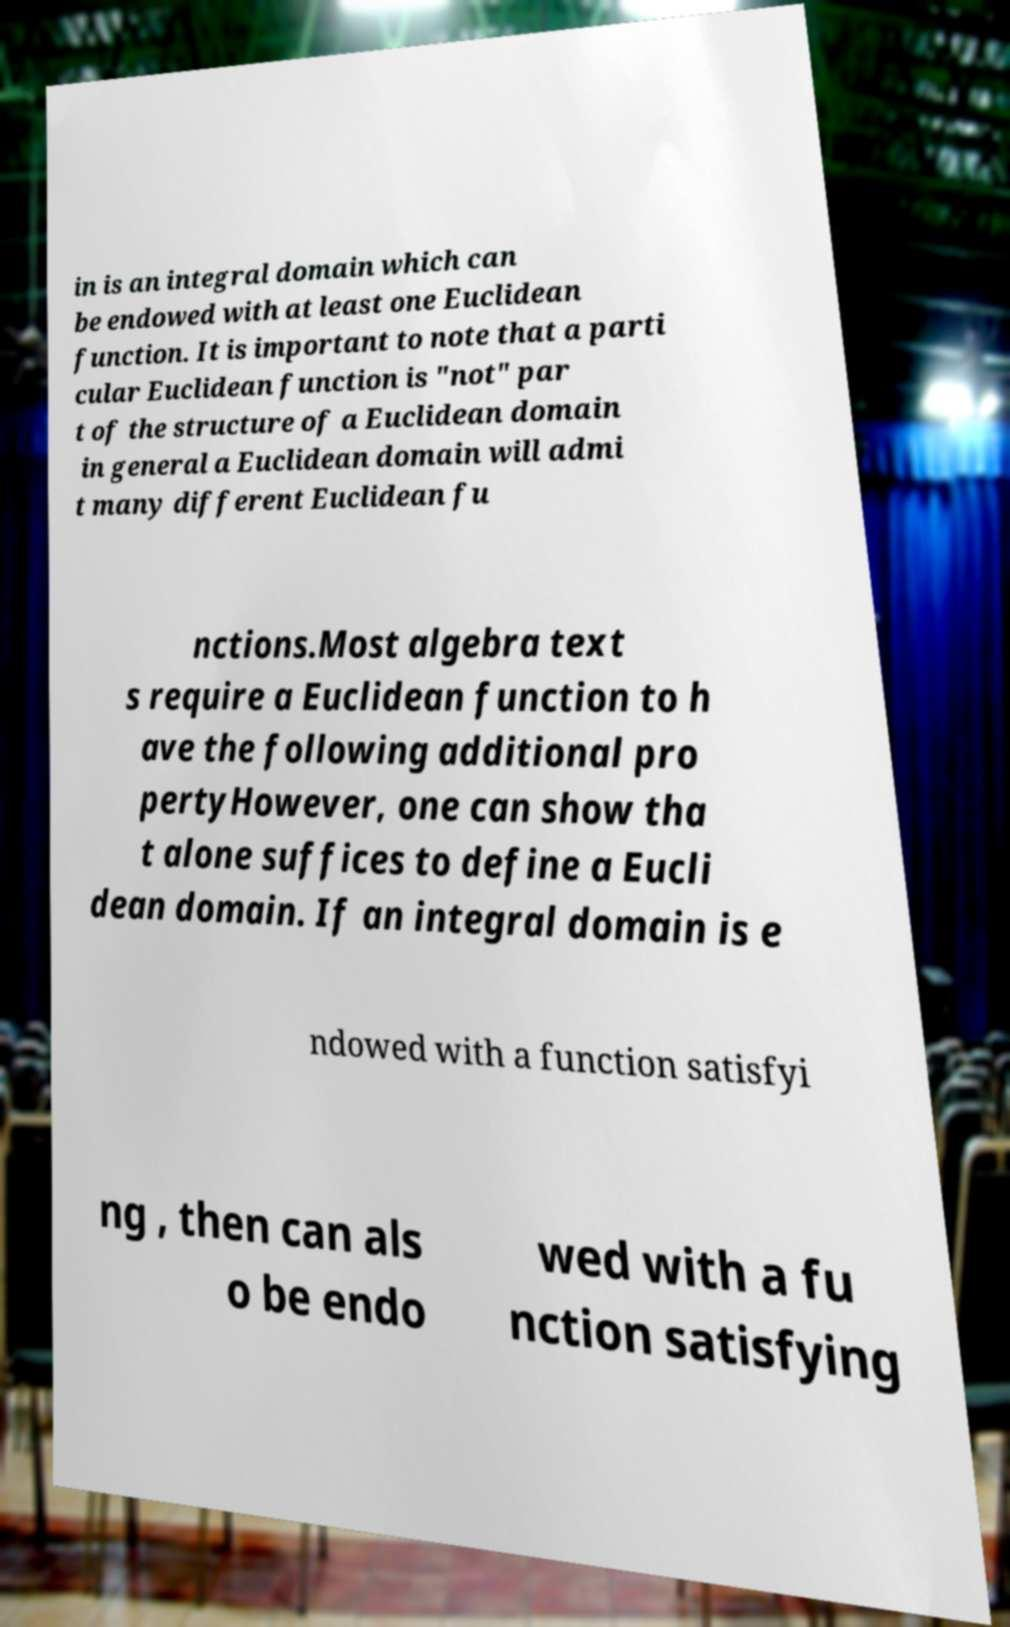I need the written content from this picture converted into text. Can you do that? in is an integral domain which can be endowed with at least one Euclidean function. It is important to note that a parti cular Euclidean function is "not" par t of the structure of a Euclidean domain in general a Euclidean domain will admi t many different Euclidean fu nctions.Most algebra text s require a Euclidean function to h ave the following additional pro pertyHowever, one can show tha t alone suffices to define a Eucli dean domain. If an integral domain is e ndowed with a function satisfyi ng , then can als o be endo wed with a fu nction satisfying 